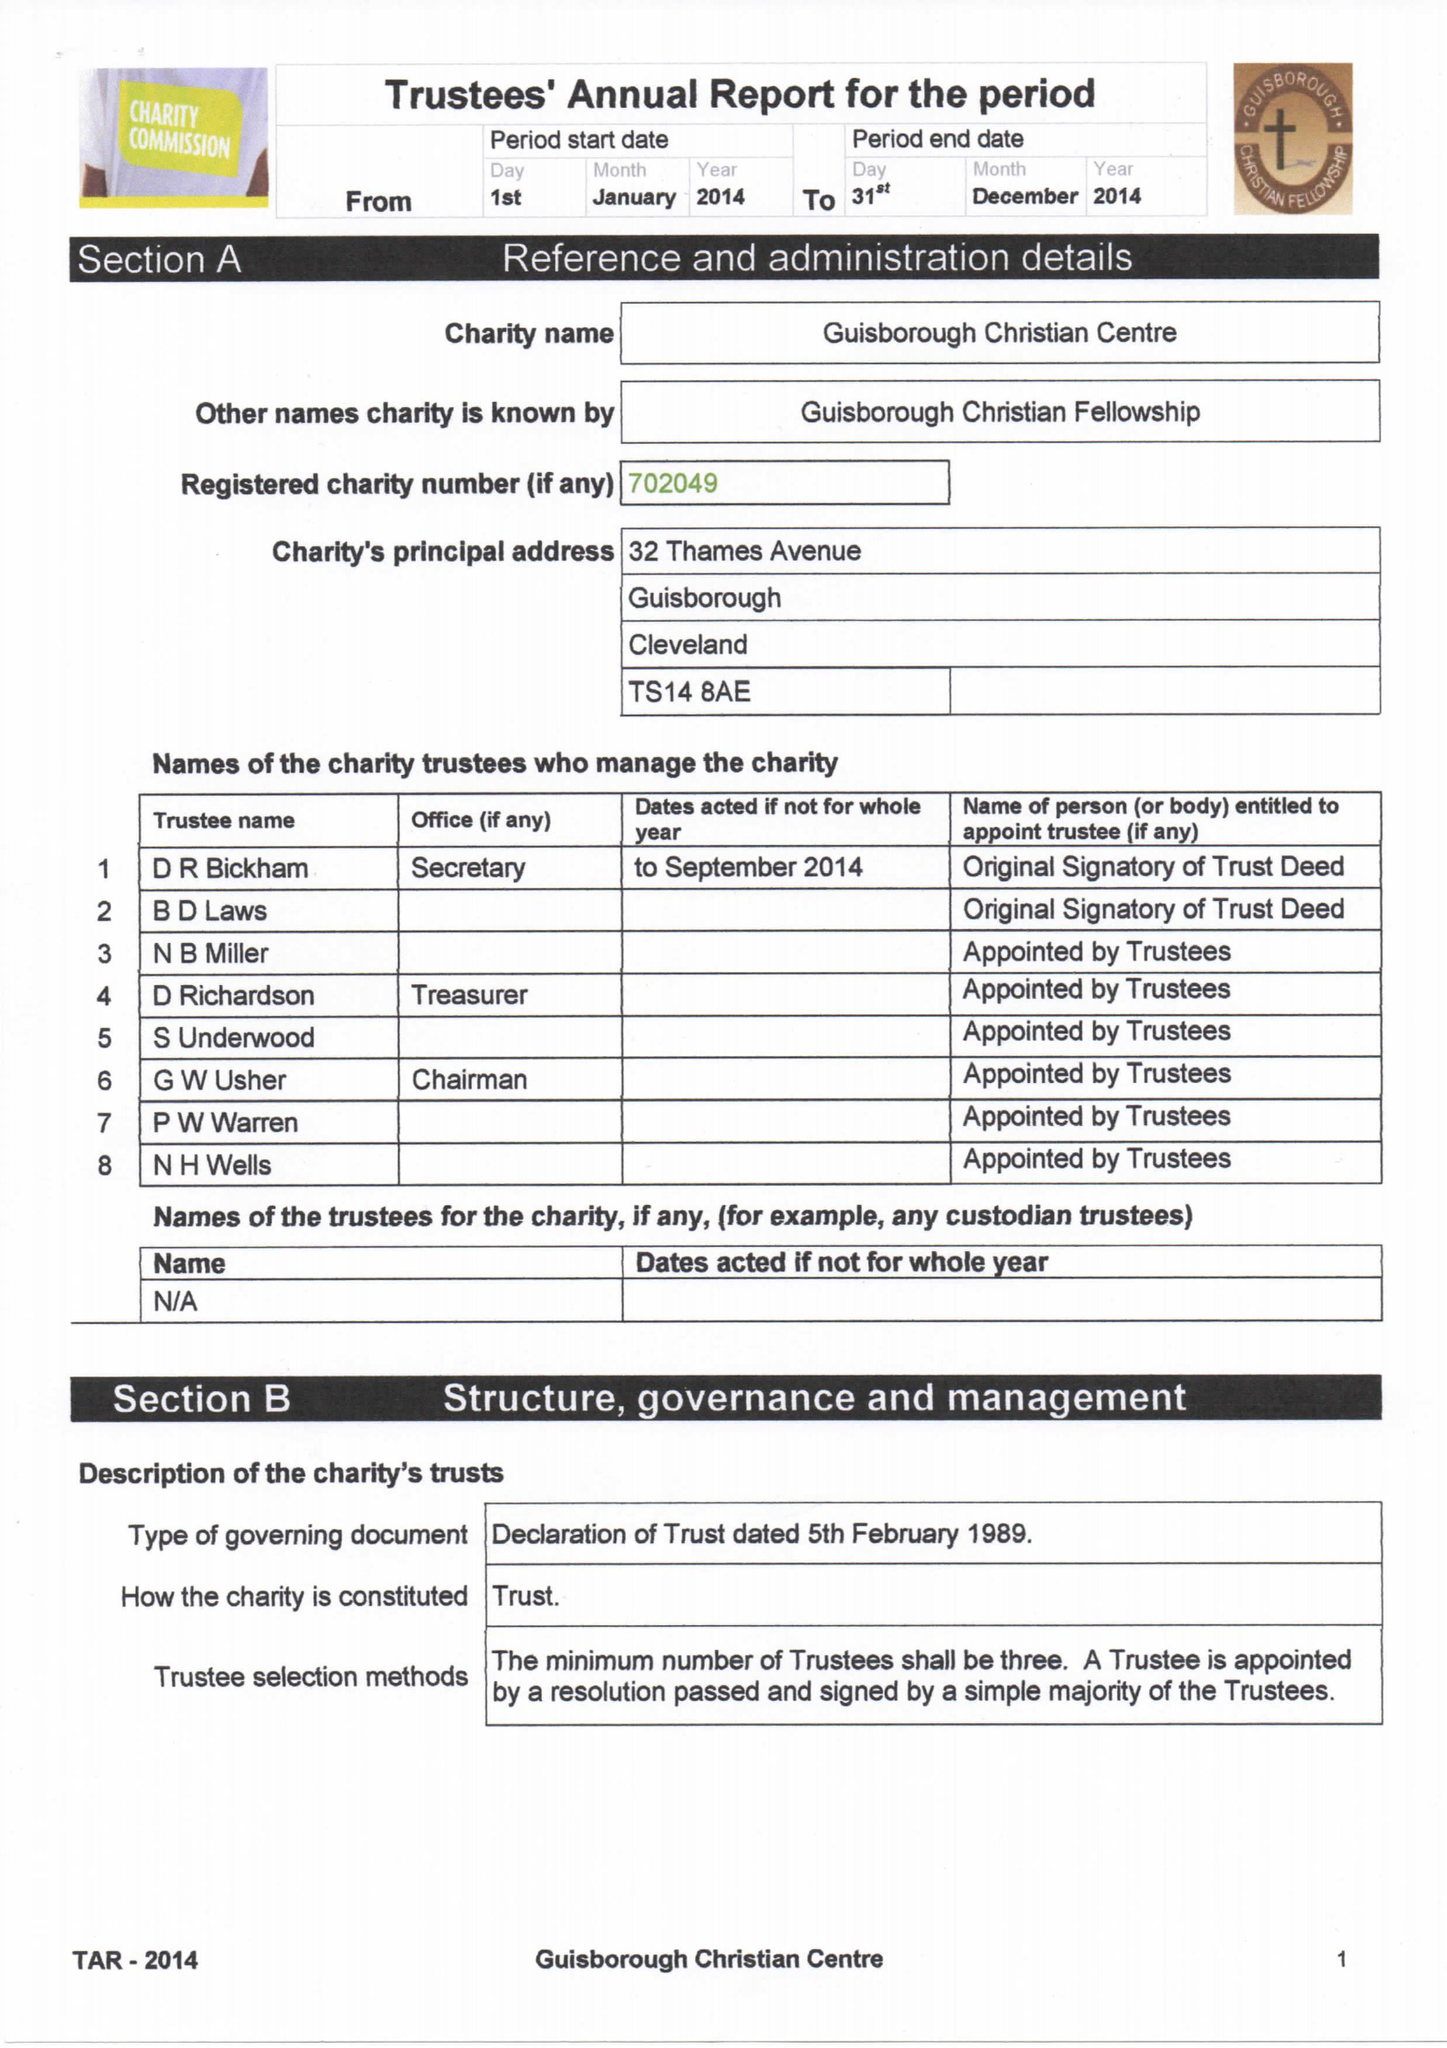What is the value for the address__post_town?
Answer the question using a single word or phrase. SALTBURN-BY-THE-SEA 